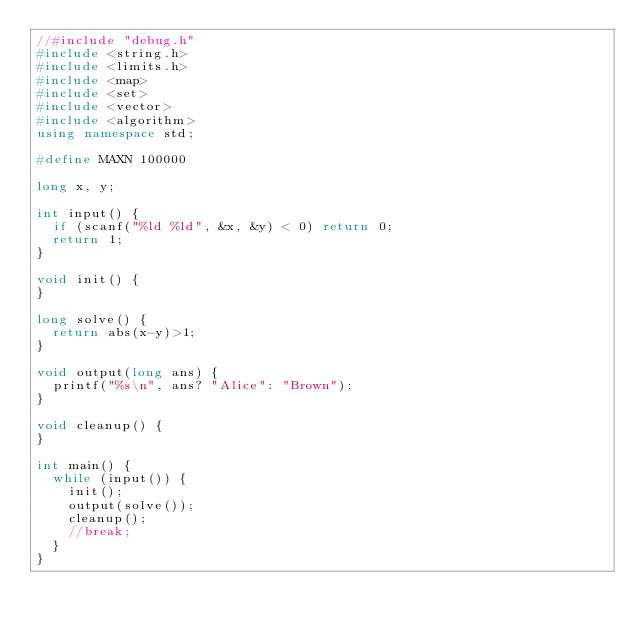Convert code to text. <code><loc_0><loc_0><loc_500><loc_500><_C++_>//#include "debug.h"
#include <string.h>
#include <limits.h>
#include <map>
#include <set>
#include <vector>
#include <algorithm>
using namespace std;

#define MAXN 100000

long x, y;

int input() {
	if (scanf("%ld %ld", &x, &y) < 0) return 0;
	return 1;
}

void init() {
}

long solve() {
	return abs(x-y)>1;
}

void output(long ans) {
	printf("%s\n", ans? "Alice": "Brown");
}

void cleanup() {
}

int main() {
	while (input()) {
		init();
		output(solve());
		cleanup();
		//break;
	}
}



</code> 